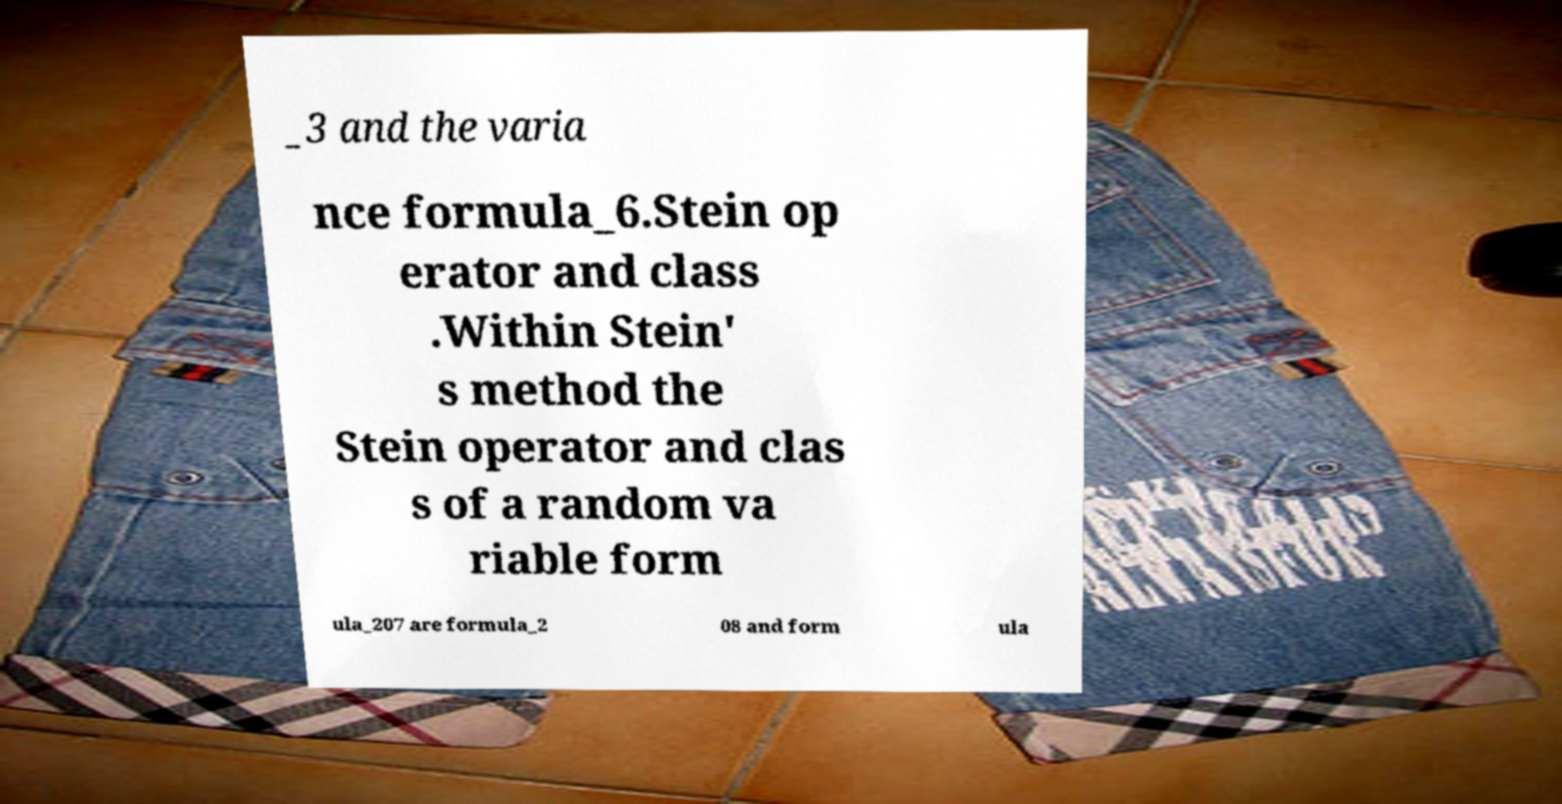Could you assist in decoding the text presented in this image and type it out clearly? _3 and the varia nce formula_6.Stein op erator and class .Within Stein' s method the Stein operator and clas s of a random va riable form ula_207 are formula_2 08 and form ula 